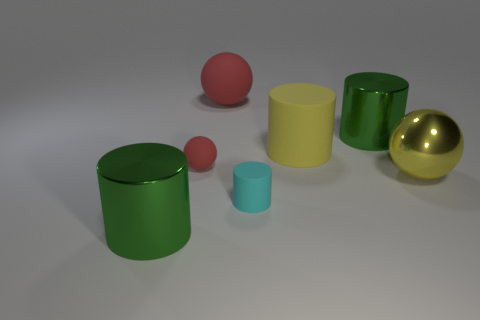How many objects are green metal cylinders behind the large yellow shiny ball or balls to the left of the cyan matte thing? 3 